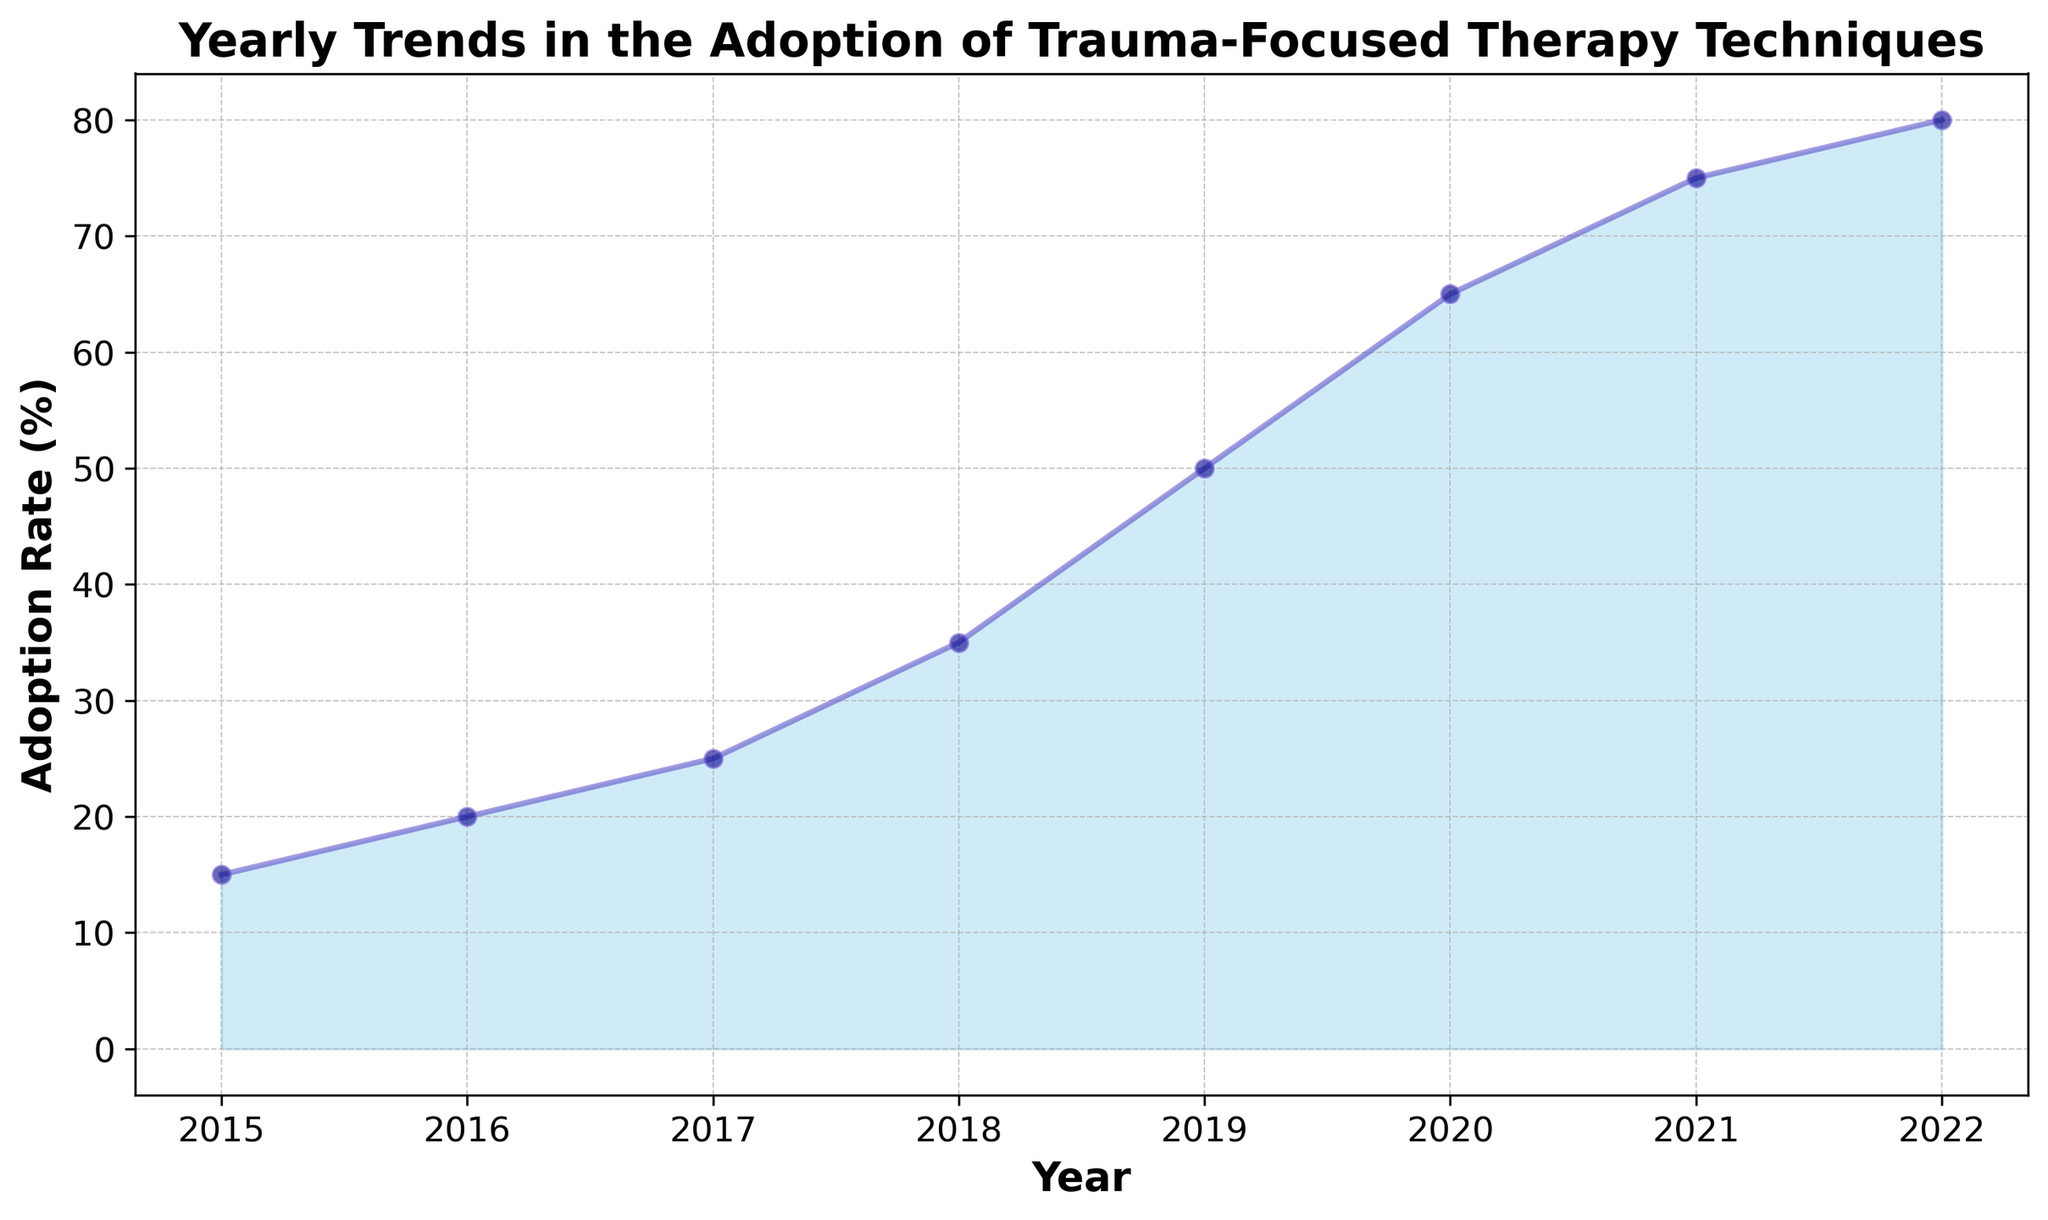What is the adoption rate in 2020? Look at the data point corresponding to the year 2020 on the x-axis and find the value on the y-axis.
Answer: 65% How did the adoption rate change from 2015 to 2018? Subtract the adoption rate in 2015 from the adoption rate in 2018. The adoption rate in 2018 is 35% and in 2015 it is 15%. So, the change is 35% - 15%.
Answer: Increased by 20% Which year had the highest adoption rate? Find the highest value on the y-axis and check which year on the x-axis corresponds to it.
Answer: 2022 What is the difference in adoption rates between 2019 and 2021? Subtract the adoption rate in 2019 from the adoption rate in 2021. The adoption rate in 2021 is 75% and in 2019 it is 50%. So, the difference is 75% - 50%.
Answer: 25% What can be said about the trend in the adoption rate from 2015 to 2022? Observe the general direction and shape of the line plot from 2015 to 2022. The adoption rate is continuously increasing from 15% in 2015 to 80% in 2022.
Answer: Steadily increasing Which year experienced the largest single-year increase in adoption rate? Compare the yearly changes in adoption rates and identify the year with the highest increase. The largest increase is from 2018 to 2019 (35% to 50%), which is a 15% increase.
Answer: 2018 to 2019 What is the average adoption rate for the years 2015 through 2022? Add the adoption rates for each year from 2015 to 2022 and divide by the number of years (8). (15 + 20 + 25 + 35 + 50 + 65 + 75 + 80) / 8.
Answer: 45.625% How does the adoption rate in 2017 compare to that in 2019? Compare the y-values for the years 2017 and 2019. The adoption rate in 2017 is 25%, and in 2019 it is 50%.
Answer: 2019 has a higher adoption rate by 25% Describe the color used to represent the adoption rate trend. Observe the fill and line color of the area chart. The area is filled with a sky blue color and the line is a slate blue with dark blue markers.
Answer: Sky blue for area, slate blue for line, dark blue for markers How many years did it take for the adoption rate to increase from 20% to above 50%? Identify the year when the adoption rate was 20% (2016) and the first year it was above 50% (2019). Calculate the difference in years.
Answer: 3 years 